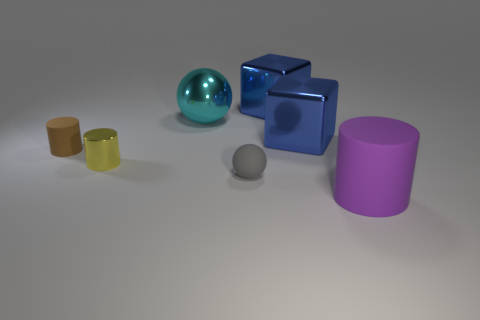There is a rubber thing that is on the left side of the purple rubber object and on the right side of the big shiny sphere; how big is it?
Provide a succinct answer. Small. Are there any other things that are the same color as the tiny matte cylinder?
Offer a very short reply. No. What is the shape of the brown thing that is made of the same material as the purple thing?
Make the answer very short. Cylinder. There is a gray thing; does it have the same shape as the big object that is in front of the brown cylinder?
Give a very brief answer. No. The small cylinder that is to the right of the matte cylinder that is behind the tiny yellow shiny cylinder is made of what material?
Give a very brief answer. Metal. Are there the same number of gray rubber spheres behind the cyan shiny sphere and blue shiny objects?
Your answer should be very brief. No. Is there any other thing that is the same material as the big purple cylinder?
Offer a very short reply. Yes. Is the color of the matte object that is to the left of the rubber ball the same as the matte object that is in front of the small gray ball?
Provide a short and direct response. No. How many matte cylinders are behind the big cylinder and right of the tiny matte ball?
Your response must be concise. 0. How many other things are there of the same shape as the tiny brown matte object?
Your answer should be very brief. 2. 